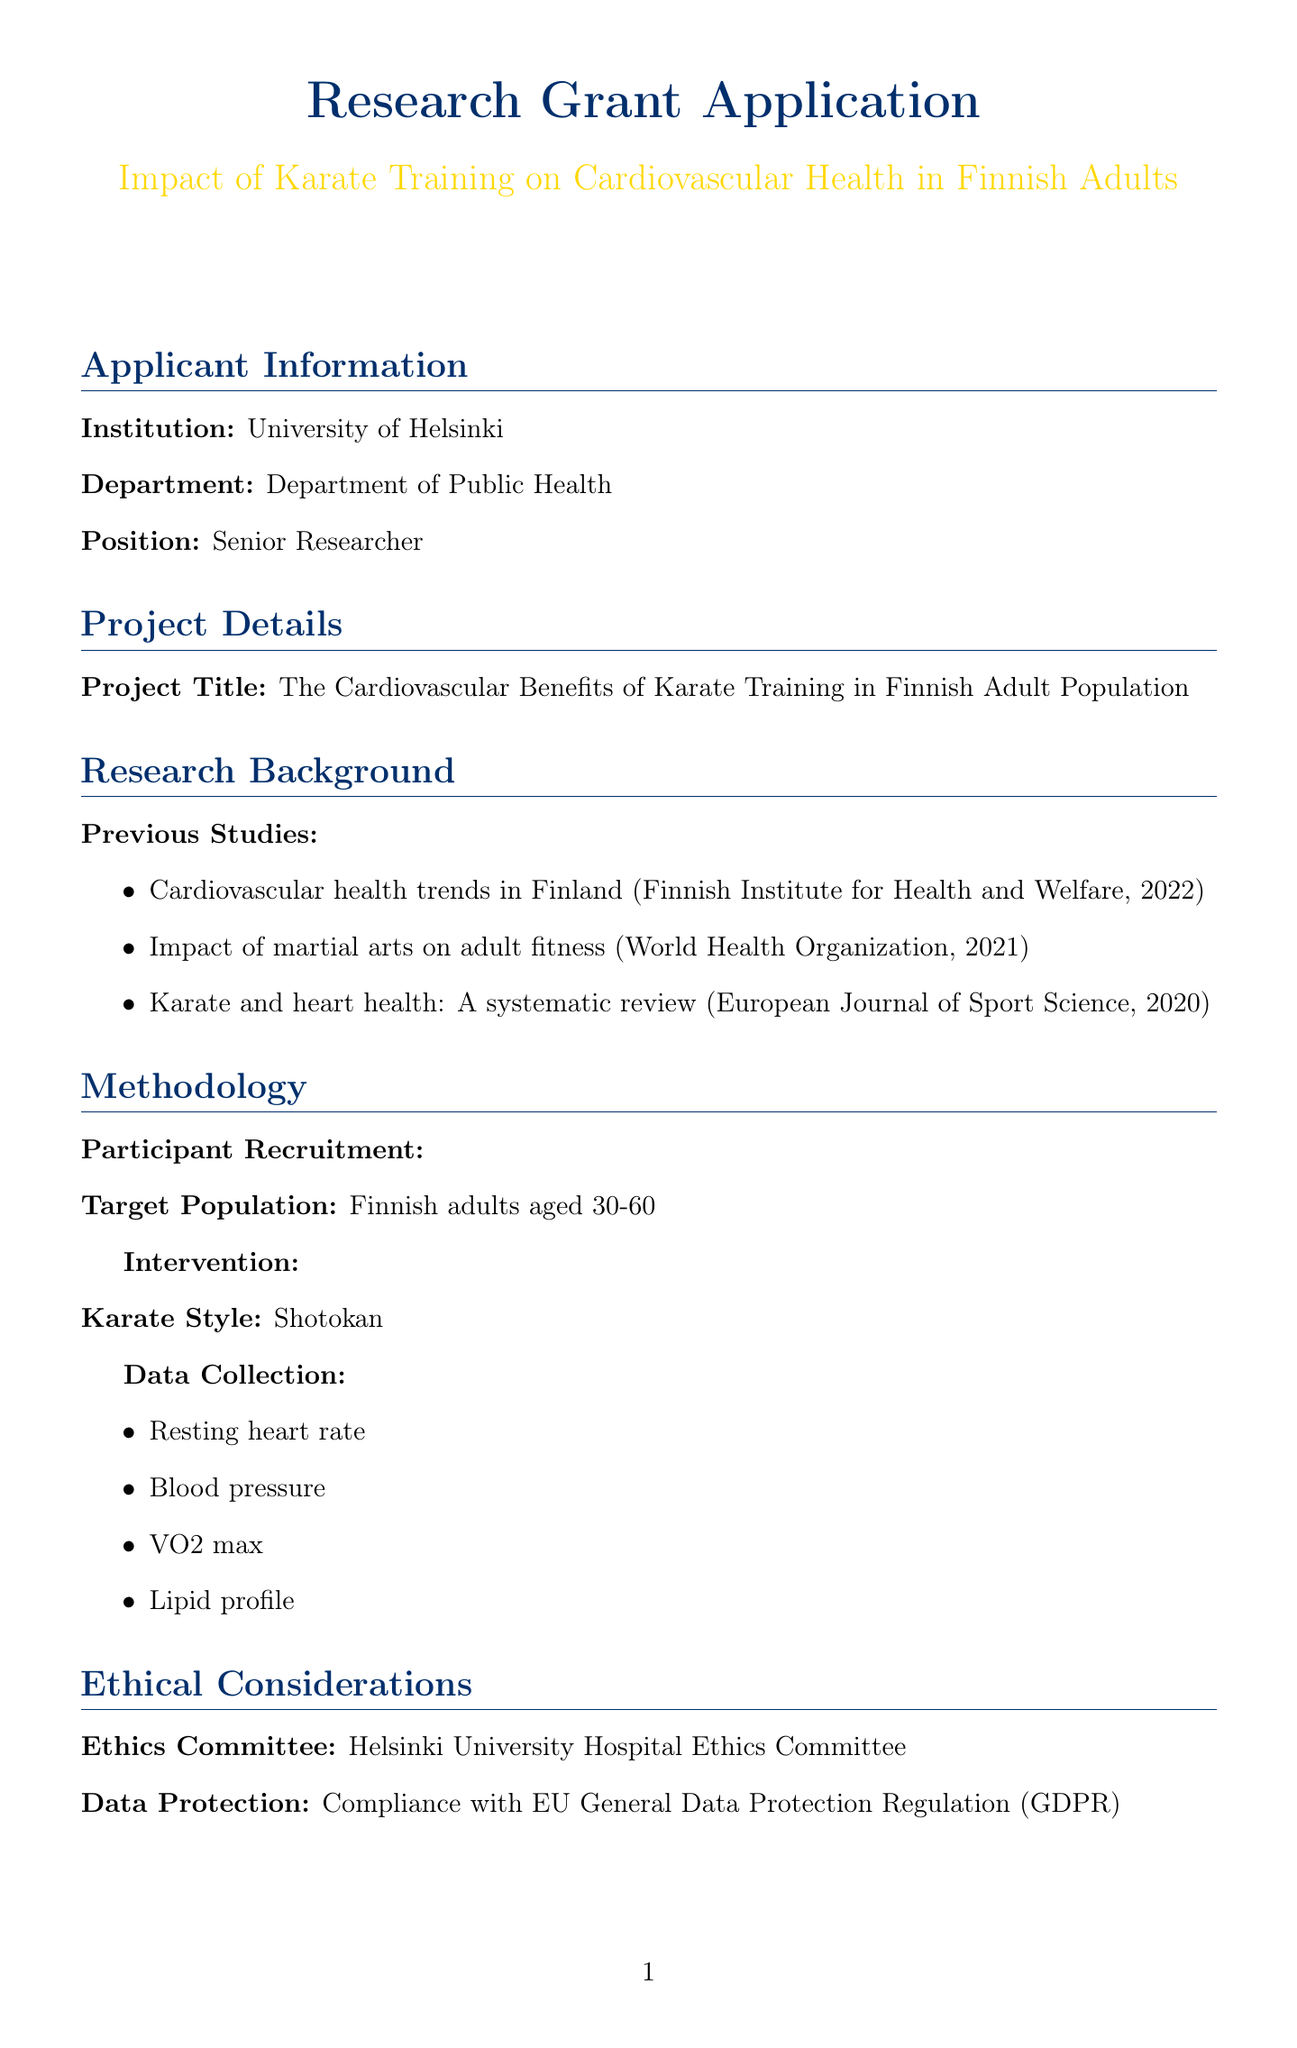What is the project title? The project title is explicitly stated in the document under project details.
Answer: The Cardiovascular Benefits of Karate Training in Finnish Adult Population What is the target population for the study? The target population is mentioned in the participant recruitment section of the methodology.
Answer: Finnish adults aged 30-60 What ethical committee is involved in the study? The ethics committee's name is provided under ethical considerations.
Answer: Helsinki University Hospital Ethics Committee What are the cardiovascular measures to be collected? The document lists specific measures under the data collection section.
Answer: Resting heart rate, Blood pressure, VO2 max, Lipid profile What software will be used for data analysis? The data analysis software is explicitly mentioned in the budget breakdown section.
Answer: SPSS Statistics Which institutions are collaborating on this research? The collaborating institutions are listed in a separate section of the document.
Answer: Finnish Heart Association, National Institute for Health and Welfare (THL), Finnish Olympic Committee What type of karate will be practiced in the intervention? The specific karate style is mentioned in the intervention section of the methodology.
Answer: Shotokan 